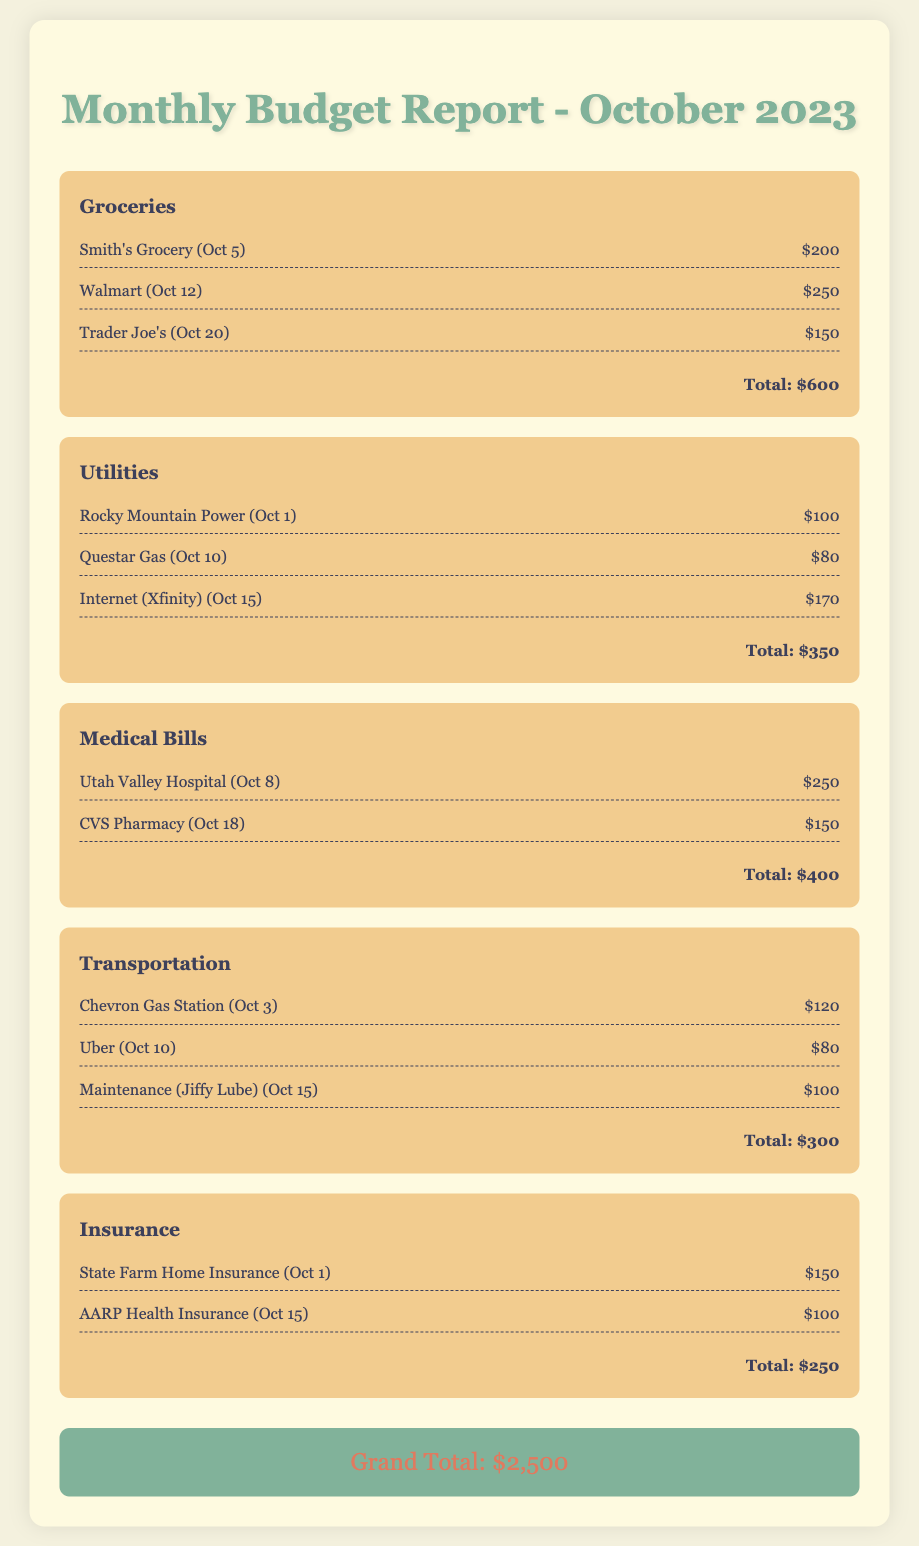What is the total amount spent on groceries? The total amount spent on groceries is listed as $600 in the document.
Answer: $600 How much was paid for Internet service? The Internet service cost from Xfinity is $170, as shown in the utilities section.
Answer: $170 Who provided the medical service on October 8? The medical service on October 8 was provided by Utah Valley Hospital, listed under medical bills.
Answer: Utah Valley Hospital What is the total for medical bills? The total for medical bills is stated as $400 in the respective category.
Answer: $400 Which utility expense was incurred on October 1? The utility expense for Rocky Mountain Power was incurred on October 1.
Answer: Rocky Mountain Power What is the grand total of all expenses? The grand total of all expenses across categories is $2,500, as stated at the end of the report.
Answer: $2,500 What is the item with the highest cost in the grocery category? The highest cost in the grocery category is $250 for Walmart, listed among the grocery expenses.
Answer: $250 How much was spent on transportation? The total amount spent on transportation is $300 according to the document details.
Answer: $300 What insurance payment is listed for October 1? The insurance payment listed for October 1 is $150 for State Farm Home Insurance.
Answer: $150 